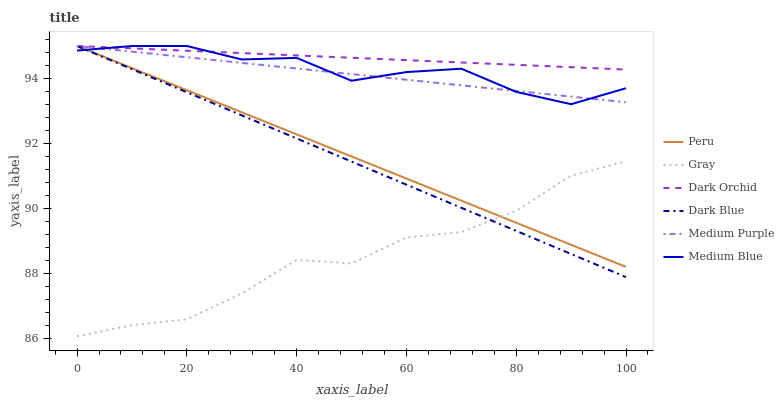Does Gray have the minimum area under the curve?
Answer yes or no. Yes. Does Dark Orchid have the maximum area under the curve?
Answer yes or no. Yes. Does Medium Blue have the minimum area under the curve?
Answer yes or no. No. Does Medium Blue have the maximum area under the curve?
Answer yes or no. No. Is Dark Blue the smoothest?
Answer yes or no. Yes. Is Gray the roughest?
Answer yes or no. Yes. Is Medium Blue the smoothest?
Answer yes or no. No. Is Medium Blue the roughest?
Answer yes or no. No. Does Gray have the lowest value?
Answer yes or no. Yes. Does Medium Blue have the lowest value?
Answer yes or no. No. Does Peru have the highest value?
Answer yes or no. Yes. Is Gray less than Dark Orchid?
Answer yes or no. Yes. Is Dark Orchid greater than Gray?
Answer yes or no. Yes. Does Medium Purple intersect Dark Blue?
Answer yes or no. Yes. Is Medium Purple less than Dark Blue?
Answer yes or no. No. Is Medium Purple greater than Dark Blue?
Answer yes or no. No. Does Gray intersect Dark Orchid?
Answer yes or no. No. 